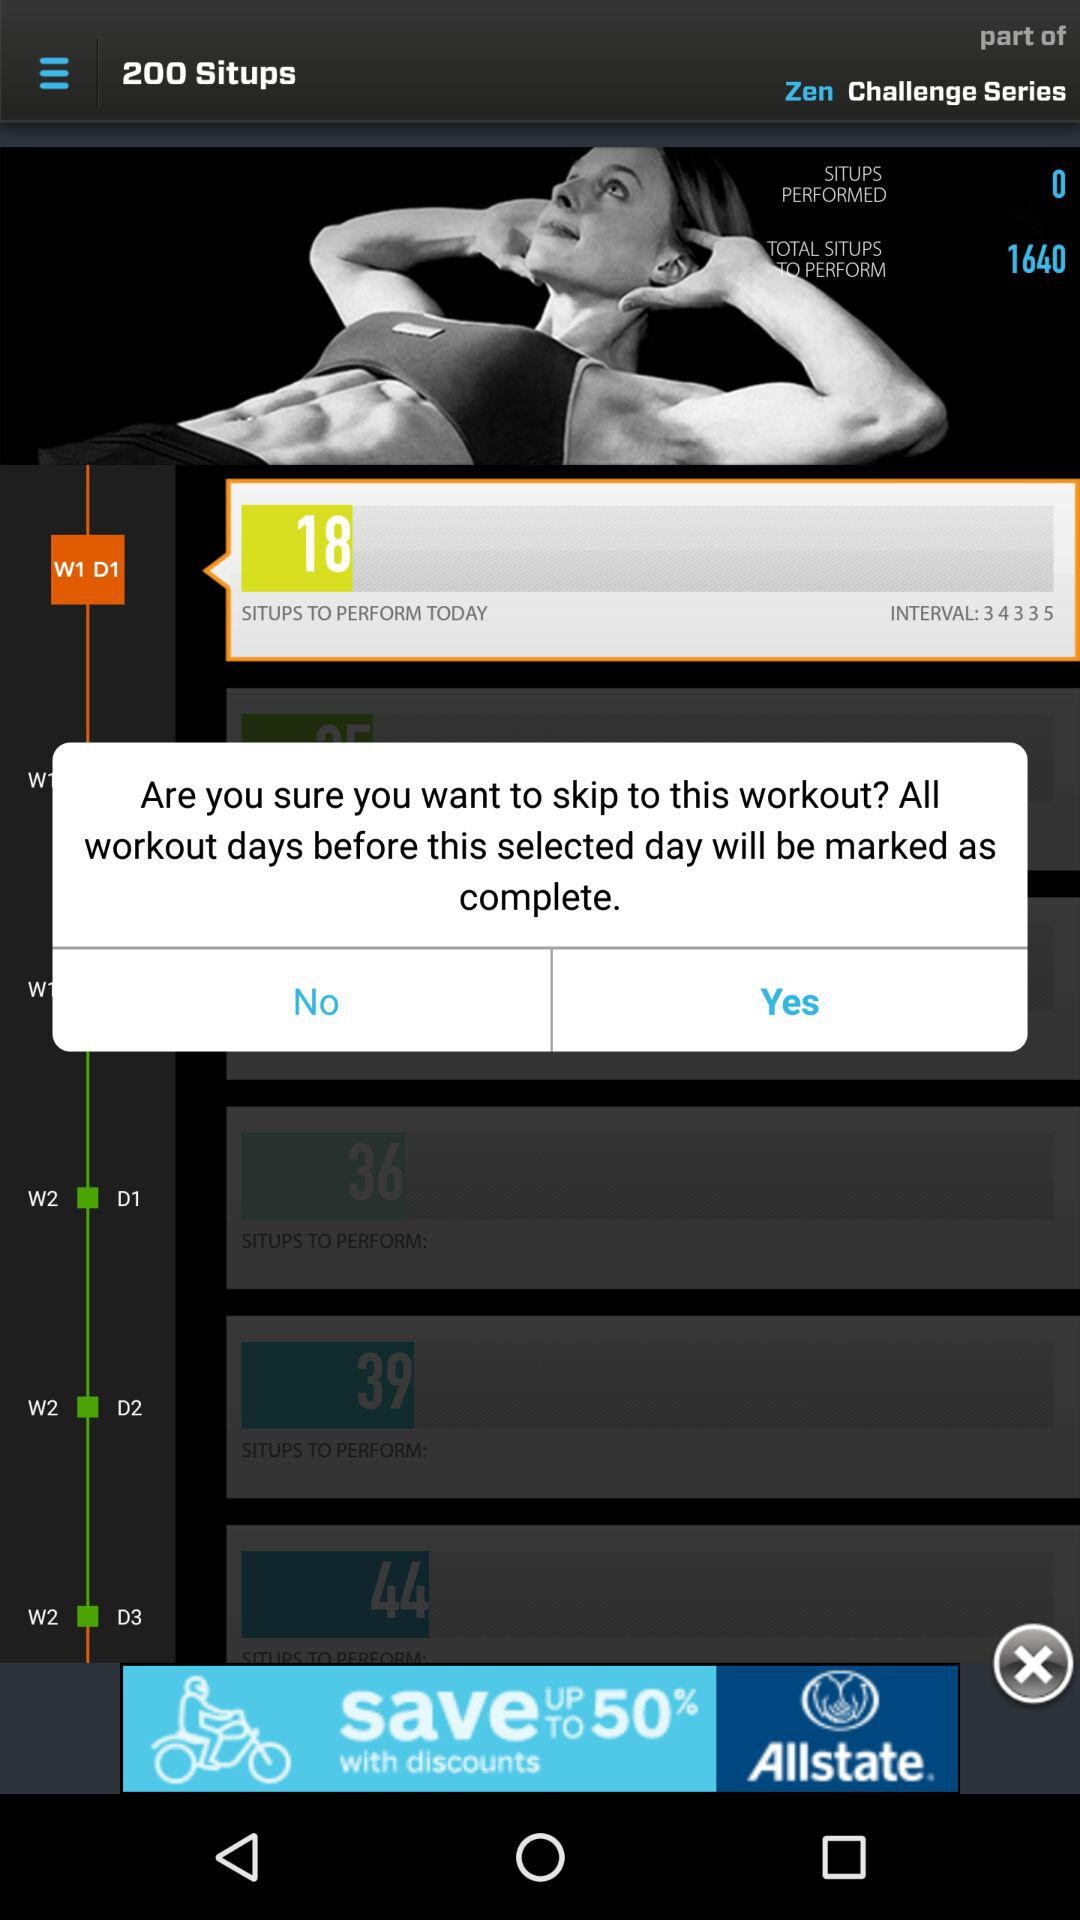How many more situps are left to perform than have been performed?
Answer the question using a single word or phrase. 1640 